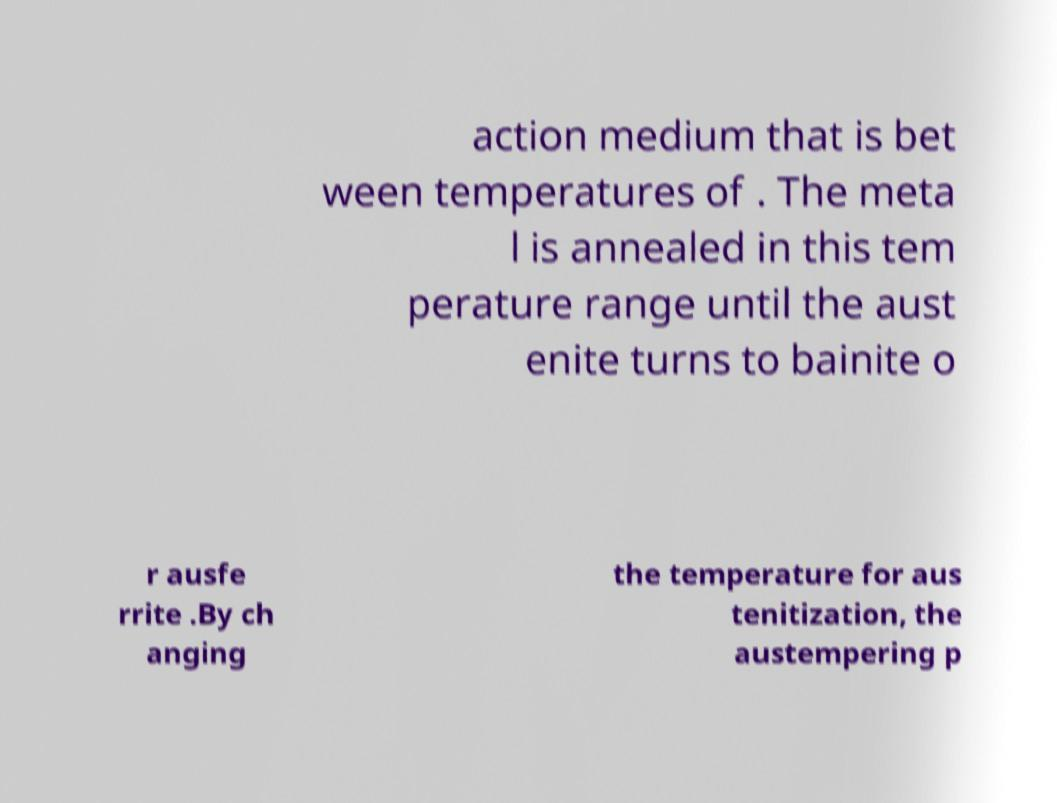I need the written content from this picture converted into text. Can you do that? action medium that is bet ween temperatures of . The meta l is annealed in this tem perature range until the aust enite turns to bainite o r ausfe rrite .By ch anging the temperature for aus tenitization, the austempering p 